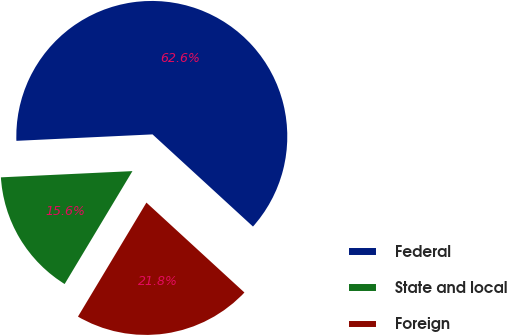Convert chart to OTSL. <chart><loc_0><loc_0><loc_500><loc_500><pie_chart><fcel>Federal<fcel>State and local<fcel>Foreign<nl><fcel>62.57%<fcel>15.64%<fcel>21.79%<nl></chart> 